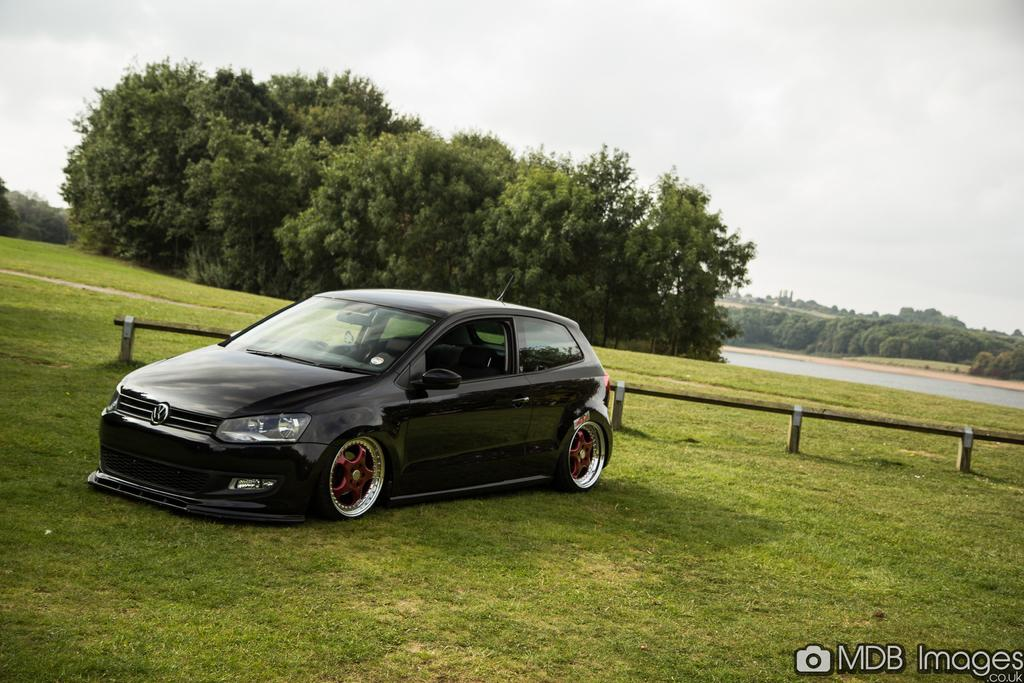What type of vehicle is in the foreground of the image? There is a black color car in the foreground of the image. Where is the car located? The car is on the grass. What can be seen in the background of the image? There is a railing, grass, trees, water, and the sky visible in the background of the image. What is the condition of the sky in the image? The sky appears to be cloudy. What type of comb is the manager using in the image? There is no comb or manager present in the image. What activity is the car participating in with the trees in the image? The car is not participating in any activity with the trees; it is simply parked on the grass. 